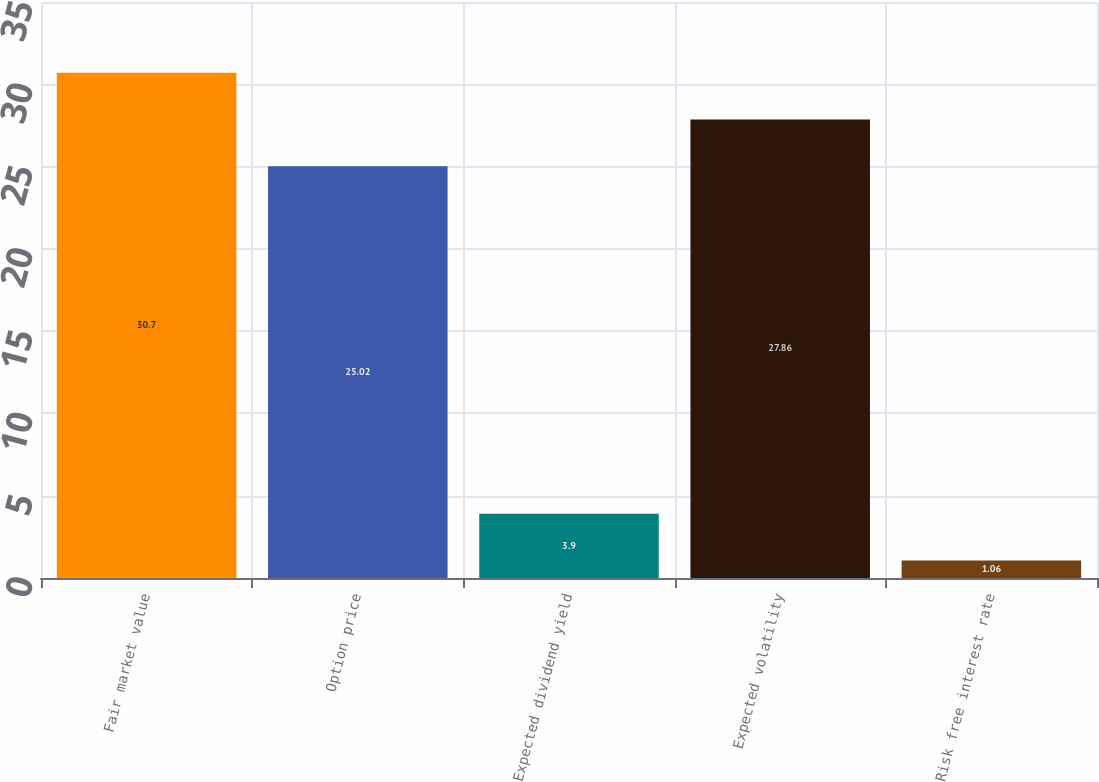Convert chart to OTSL. <chart><loc_0><loc_0><loc_500><loc_500><bar_chart><fcel>Fair market value<fcel>Option price<fcel>Expected dividend yield<fcel>Expected volatility<fcel>Risk free interest rate<nl><fcel>30.7<fcel>25.02<fcel>3.9<fcel>27.86<fcel>1.06<nl></chart> 